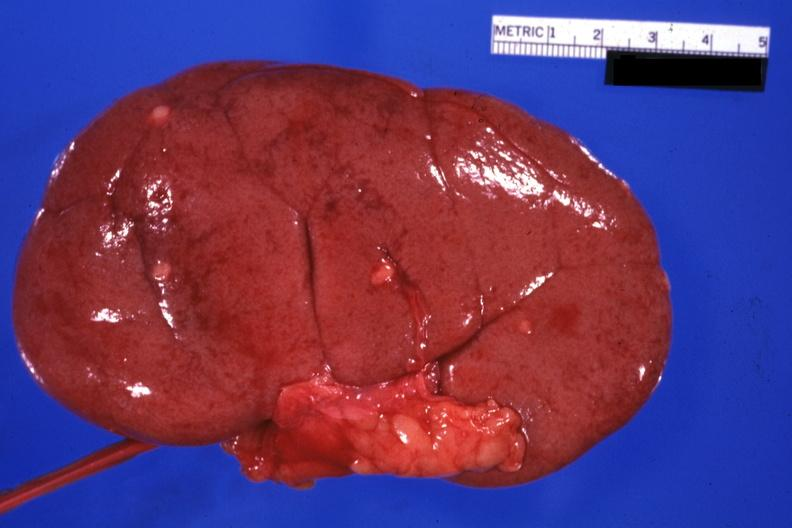how is external view with capsule removed lesions easily seen?
Answer the question using a single word or phrase. Small 